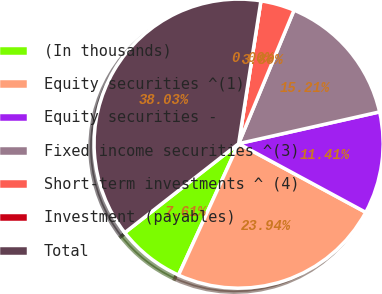Convert chart to OTSL. <chart><loc_0><loc_0><loc_500><loc_500><pie_chart><fcel>(In thousands)<fcel>Equity securities ^(1)<fcel>Equity securities -<fcel>Fixed income securities ^(3)<fcel>Short-term investments ^ (4)<fcel>Investment (payables)<fcel>Total<nl><fcel>7.61%<fcel>23.94%<fcel>11.41%<fcel>15.21%<fcel>3.8%<fcel>0.0%<fcel>38.03%<nl></chart> 